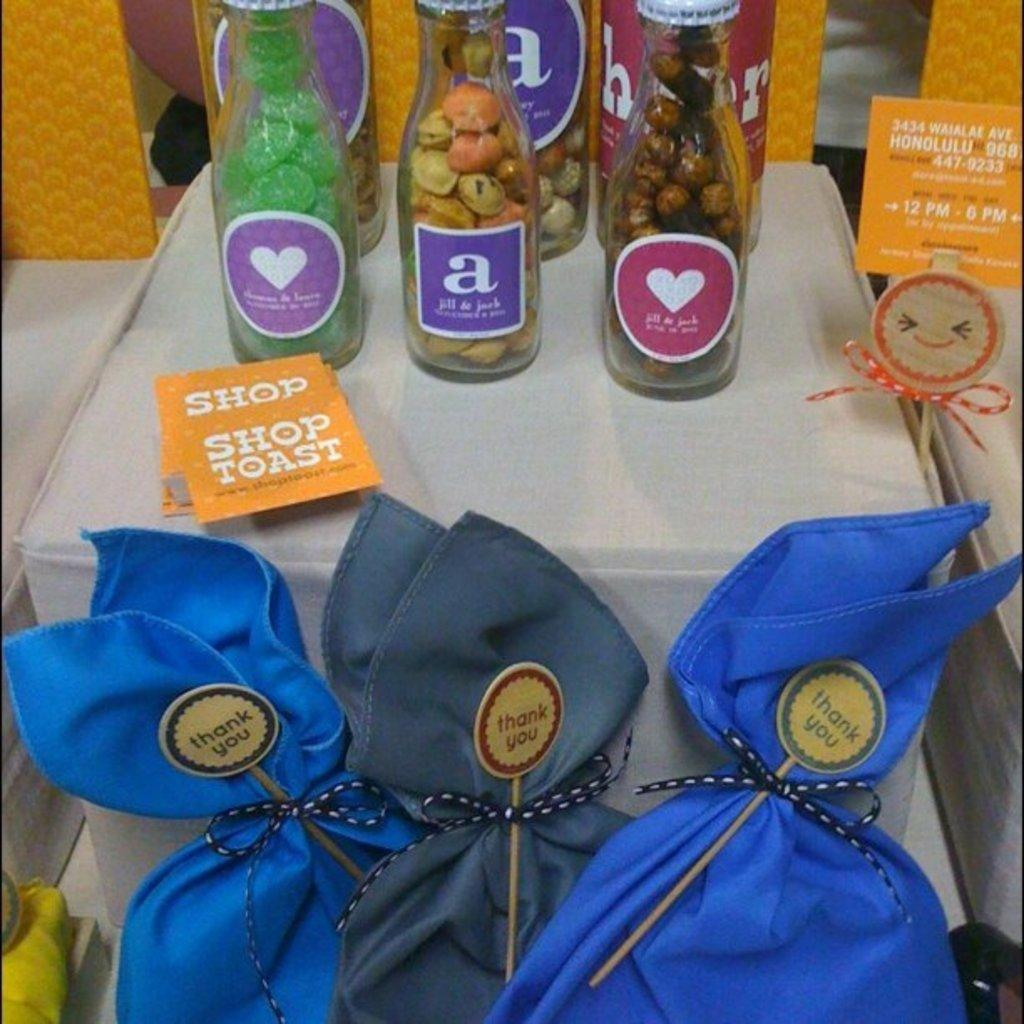What type of furniture is present in the image? There is a table in the image. How is the table decorated or covered? The table is covered by a white cloth. How many bags are on the table? There are three bags on the table. What else can be seen on the table besides the bags? There are bottles on the table. What type of lumber is used to construct the table in the image? There is no information about the type of lumber used to construct the table in the image. Can you see a goose on the table in the image? No, there is no goose present on the table in the image. 